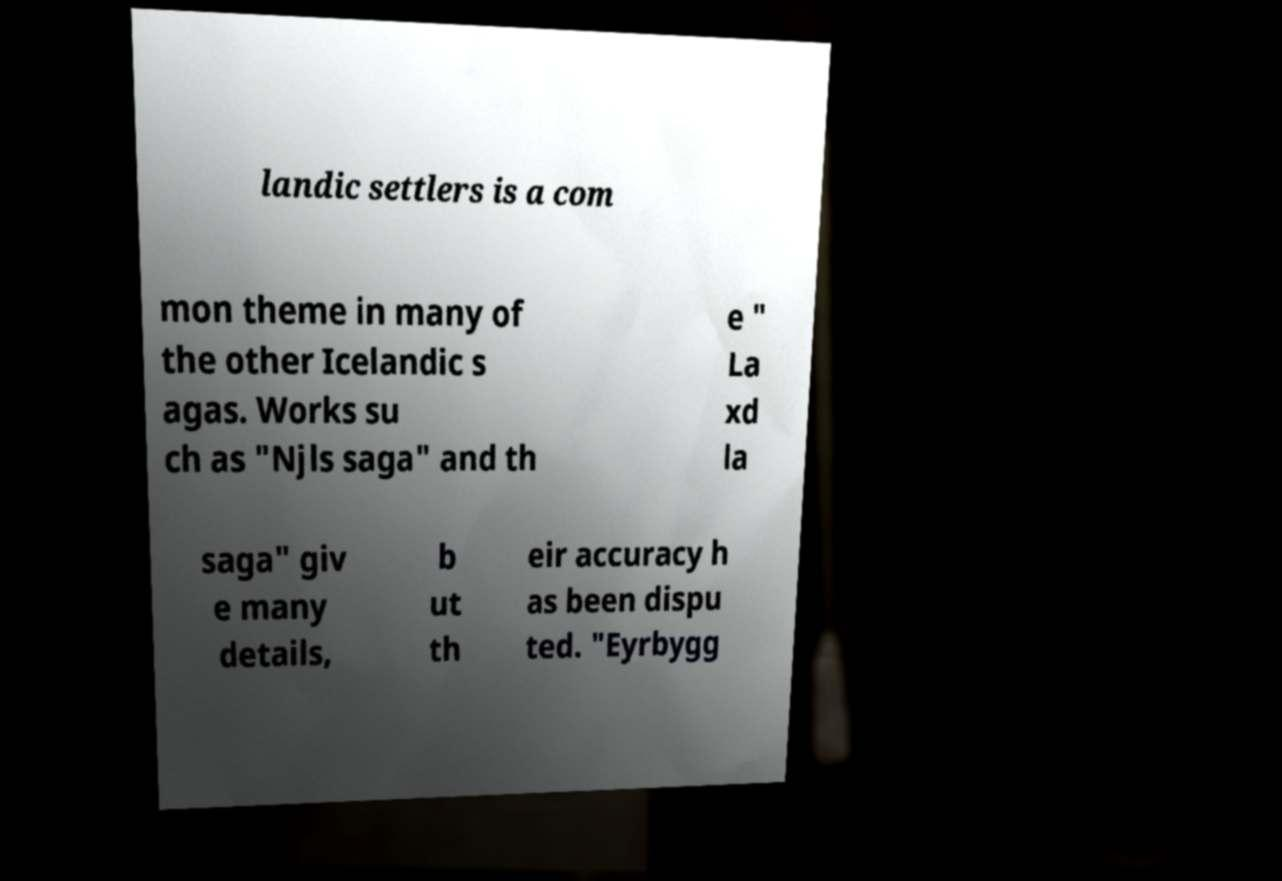There's text embedded in this image that I need extracted. Can you transcribe it verbatim? landic settlers is a com mon theme in many of the other Icelandic s agas. Works su ch as "Njls saga" and th e " La xd la saga" giv e many details, b ut th eir accuracy h as been dispu ted. "Eyrbygg 